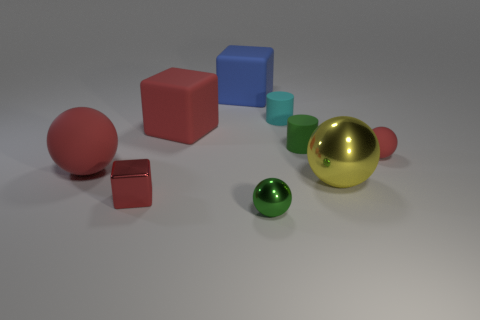Subtract all balls. How many objects are left? 5 Add 8 big red blocks. How many big red blocks are left? 9 Add 3 big matte cubes. How many big matte cubes exist? 5 Subtract 0 green blocks. How many objects are left? 9 Subtract all green metal cubes. Subtract all green metal things. How many objects are left? 8 